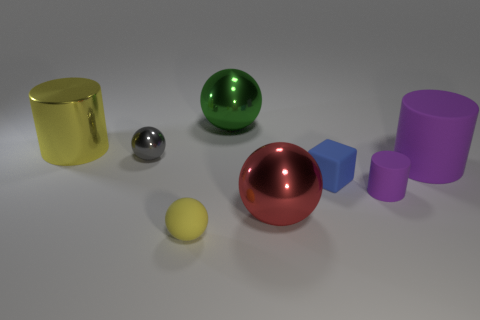Is the number of balls that are on the right side of the small matte ball greater than the number of large brown matte spheres?
Offer a very short reply. Yes. Do the gray object and the shiny thing that is to the right of the green sphere have the same shape?
Make the answer very short. Yes. Is there any other thing that is the same size as the red shiny sphere?
Ensure brevity in your answer.  Yes. The red object that is the same shape as the big green shiny object is what size?
Your answer should be compact. Large. Are there more yellow metal cylinders than tiny objects?
Give a very brief answer. No. Does the big yellow object have the same shape as the small purple rubber object?
Your answer should be very brief. Yes. What is the tiny sphere that is in front of the red ball that is in front of the green ball made of?
Give a very brief answer. Rubber. What material is the big object that is the same color as the small rubber sphere?
Make the answer very short. Metal. Is the size of the red ball the same as the rubber ball?
Your response must be concise. No. There is a large thing that is behind the big yellow cylinder; are there any cylinders that are on the left side of it?
Your answer should be compact. Yes. 